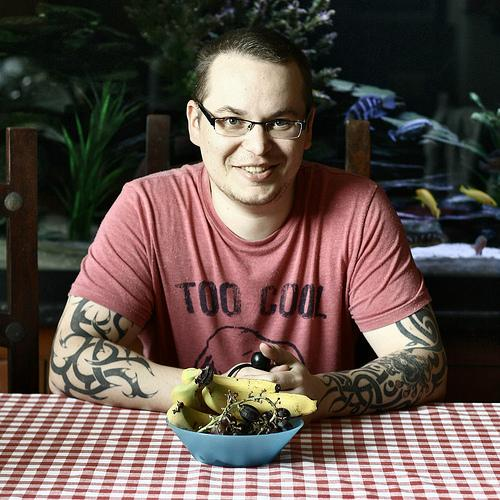What sort of diet might the person at the table have?

Choices:
A) white food
B) carnivore
C) vegan
D) fasting vegan 